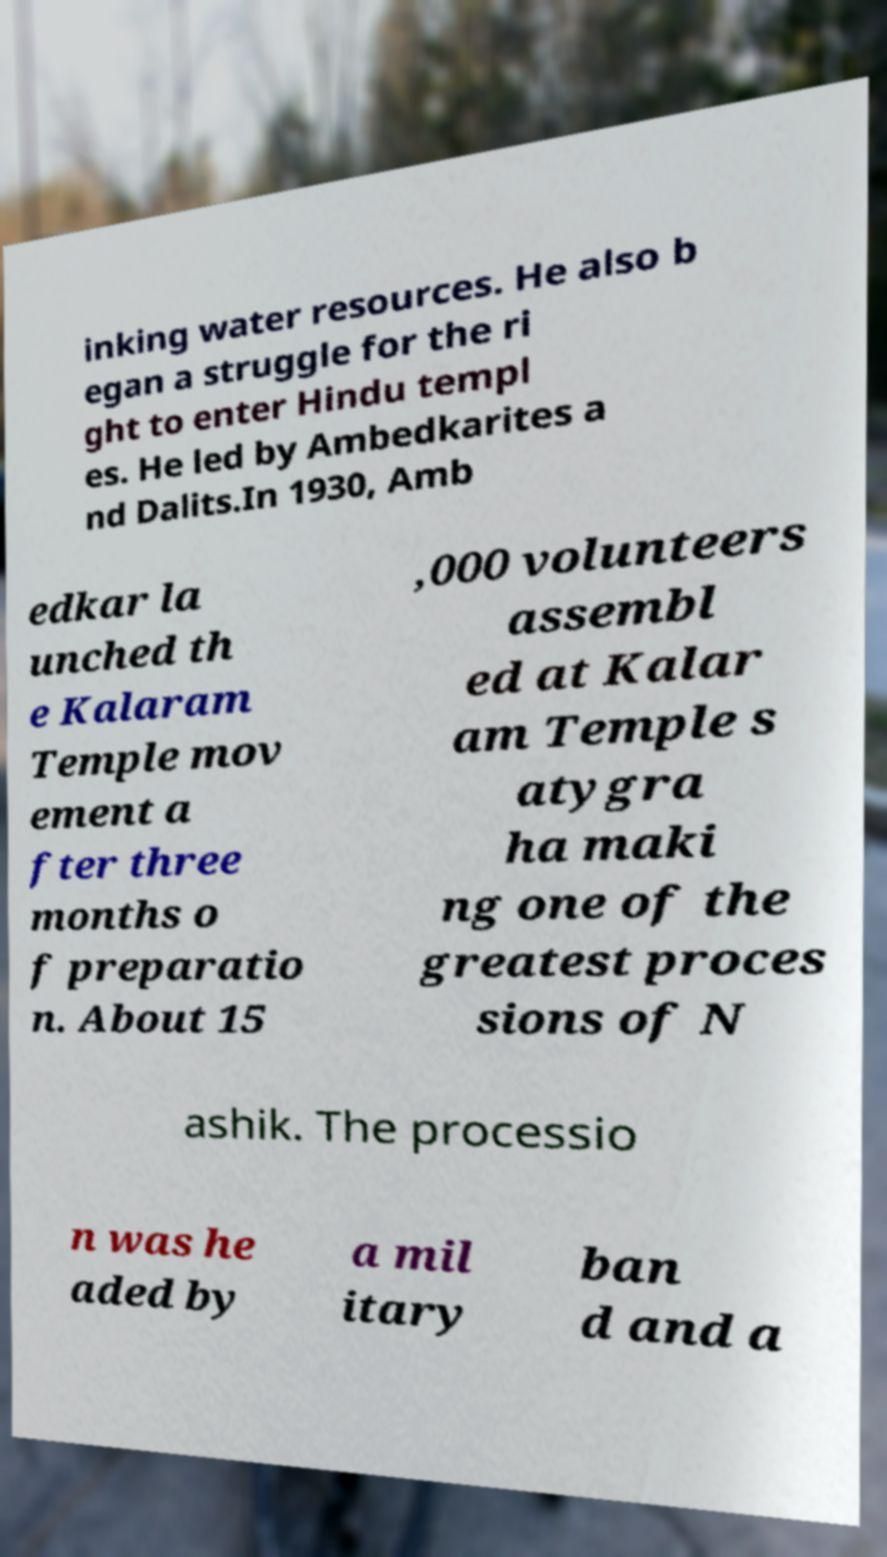What messages or text are displayed in this image? I need them in a readable, typed format. inking water resources. He also b egan a struggle for the ri ght to enter Hindu templ es. He led by Ambedkarites a nd Dalits.In 1930, Amb edkar la unched th e Kalaram Temple mov ement a fter three months o f preparatio n. About 15 ,000 volunteers assembl ed at Kalar am Temple s atygra ha maki ng one of the greatest proces sions of N ashik. The processio n was he aded by a mil itary ban d and a 